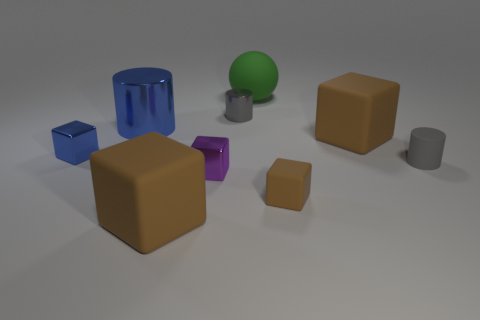Is the number of big brown cubes behind the small purple object less than the number of small brown objects to the left of the large blue metallic object?
Your answer should be compact. No. How many things are either matte objects to the left of the rubber ball or large red cubes?
Offer a very short reply. 1. There is a tiny gray object behind the big brown matte thing that is right of the small brown matte block; what is its shape?
Provide a short and direct response. Cylinder. Are there any green rubber cubes of the same size as the green thing?
Keep it short and to the point. No. Is the number of large cyan shiny cylinders greater than the number of blue metallic blocks?
Give a very brief answer. No. Is the size of the brown block that is on the right side of the tiny brown block the same as the metal thing that is in front of the small blue thing?
Your response must be concise. No. How many rubber objects are left of the tiny brown block and in front of the tiny gray metallic cylinder?
Provide a short and direct response. 1. There is another small rubber thing that is the same shape as the small purple thing; what color is it?
Offer a very short reply. Brown. Is the number of large cubes less than the number of cylinders?
Your answer should be very brief. Yes. Does the sphere have the same size as the cylinder left of the gray metallic cylinder?
Offer a very short reply. Yes. 